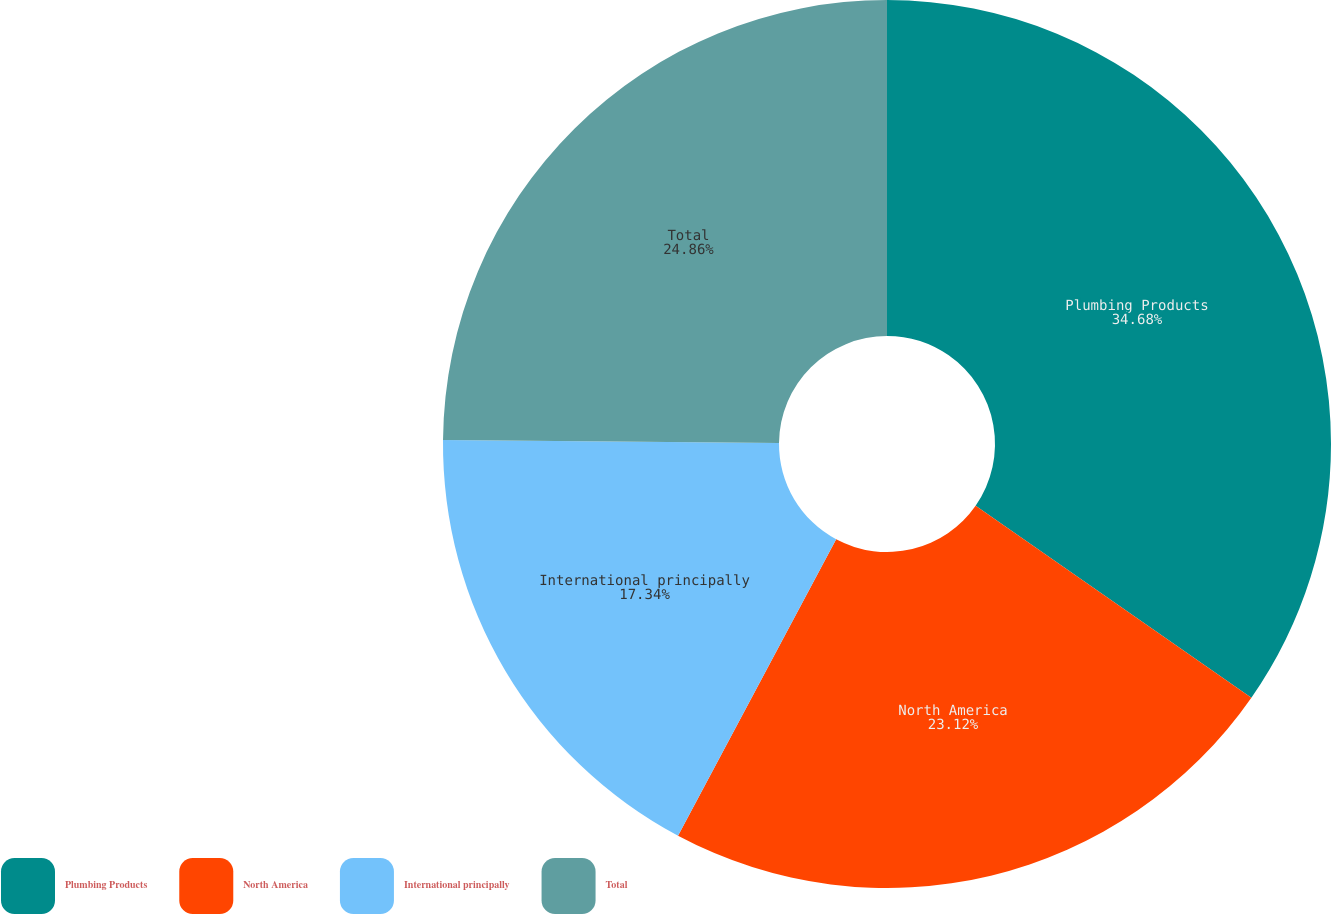<chart> <loc_0><loc_0><loc_500><loc_500><pie_chart><fcel>Plumbing Products<fcel>North America<fcel>International principally<fcel>Total<nl><fcel>34.68%<fcel>23.12%<fcel>17.34%<fcel>24.86%<nl></chart> 